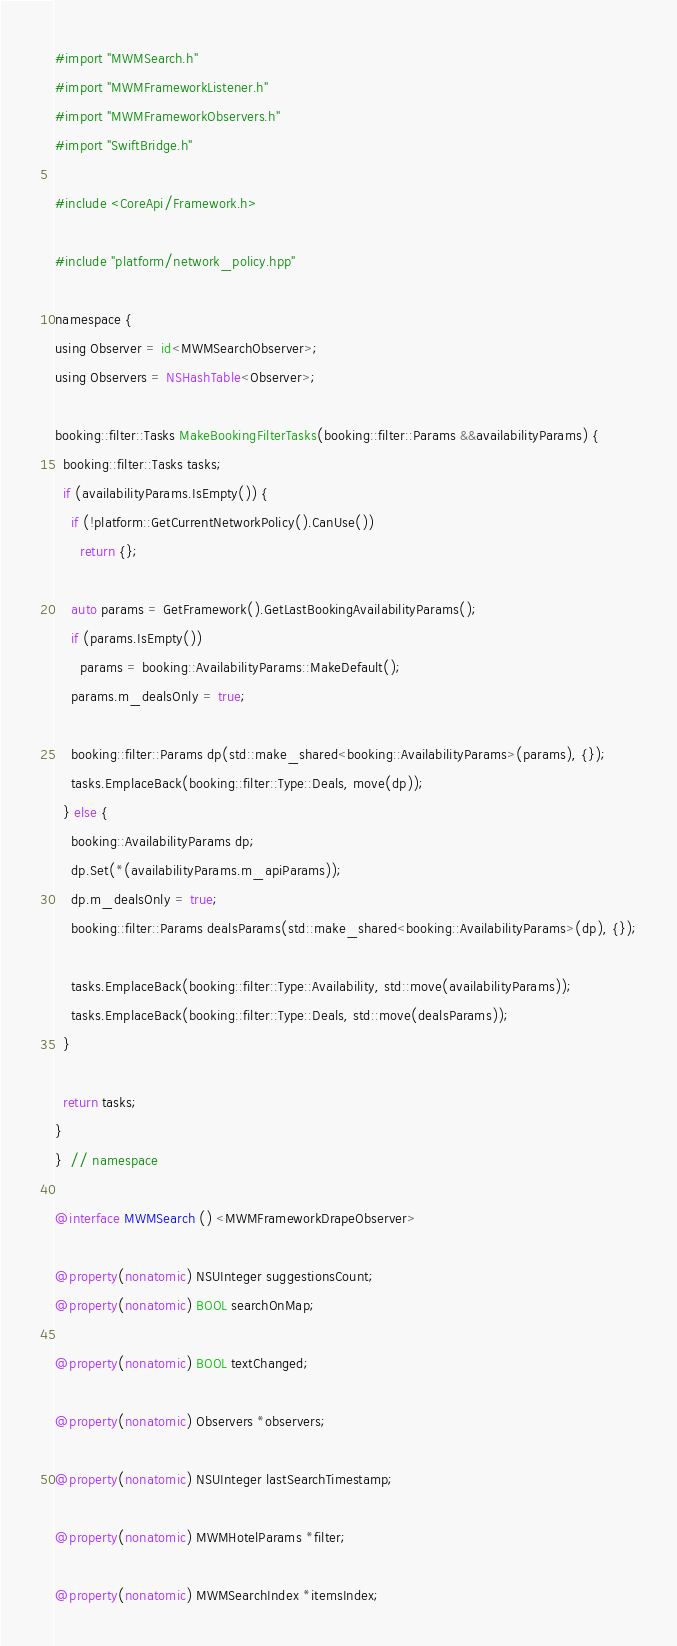<code> <loc_0><loc_0><loc_500><loc_500><_ObjectiveC_>#import "MWMSearch.h"
#import "MWMFrameworkListener.h"
#import "MWMFrameworkObservers.h"
#import "SwiftBridge.h"

#include <CoreApi/Framework.h>

#include "platform/network_policy.hpp"

namespace {
using Observer = id<MWMSearchObserver>;
using Observers = NSHashTable<Observer>;

booking::filter::Tasks MakeBookingFilterTasks(booking::filter::Params &&availabilityParams) {
  booking::filter::Tasks tasks;
  if (availabilityParams.IsEmpty()) {
    if (!platform::GetCurrentNetworkPolicy().CanUse())
      return {};

    auto params = GetFramework().GetLastBookingAvailabilityParams();
    if (params.IsEmpty())
      params = booking::AvailabilityParams::MakeDefault();
    params.m_dealsOnly = true;

    booking::filter::Params dp(std::make_shared<booking::AvailabilityParams>(params), {});
    tasks.EmplaceBack(booking::filter::Type::Deals, move(dp));
  } else {
    booking::AvailabilityParams dp;
    dp.Set(*(availabilityParams.m_apiParams));
    dp.m_dealsOnly = true;
    booking::filter::Params dealsParams(std::make_shared<booking::AvailabilityParams>(dp), {});

    tasks.EmplaceBack(booking::filter::Type::Availability, std::move(availabilityParams));
    tasks.EmplaceBack(booking::filter::Type::Deals, std::move(dealsParams));
  }

  return tasks;
}
}  // namespace

@interface MWMSearch () <MWMFrameworkDrapeObserver>

@property(nonatomic) NSUInteger suggestionsCount;
@property(nonatomic) BOOL searchOnMap;

@property(nonatomic) BOOL textChanged;

@property(nonatomic) Observers *observers;

@property(nonatomic) NSUInteger lastSearchTimestamp;

@property(nonatomic) MWMHotelParams *filter;

@property(nonatomic) MWMSearchIndex *itemsIndex;
</code> 